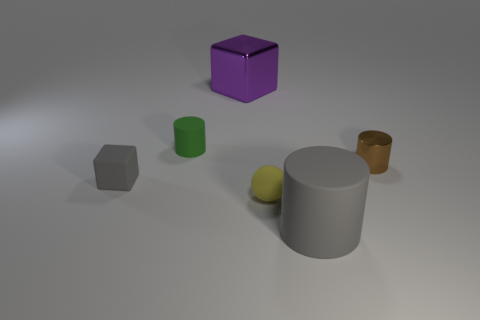There is a thing that is both to the left of the big gray rubber cylinder and right of the large block; what size is it?
Your response must be concise. Small. What is the gray object behind the big gray rubber object made of?
Provide a succinct answer. Rubber. Are there any other tiny rubber things of the same shape as the tiny yellow rubber thing?
Keep it short and to the point. No. What number of small metal objects are the same shape as the green matte object?
Offer a very short reply. 1. Is the size of the block on the left side of the big purple metal object the same as the gray thing that is on the right side of the small matte ball?
Offer a very short reply. No. There is a small matte object to the left of the cylinder that is left of the large gray matte cylinder; what shape is it?
Provide a succinct answer. Cube. Are there an equal number of gray rubber cylinders that are on the right side of the brown cylinder and tiny brown metallic cylinders?
Keep it short and to the point. No. The tiny cylinder right of the small matte thing behind the gray rubber object that is behind the big rubber cylinder is made of what material?
Offer a terse response. Metal. Are there any metallic cylinders that have the same size as the gray cube?
Provide a short and direct response. Yes. What is the shape of the yellow thing?
Keep it short and to the point. Sphere. 